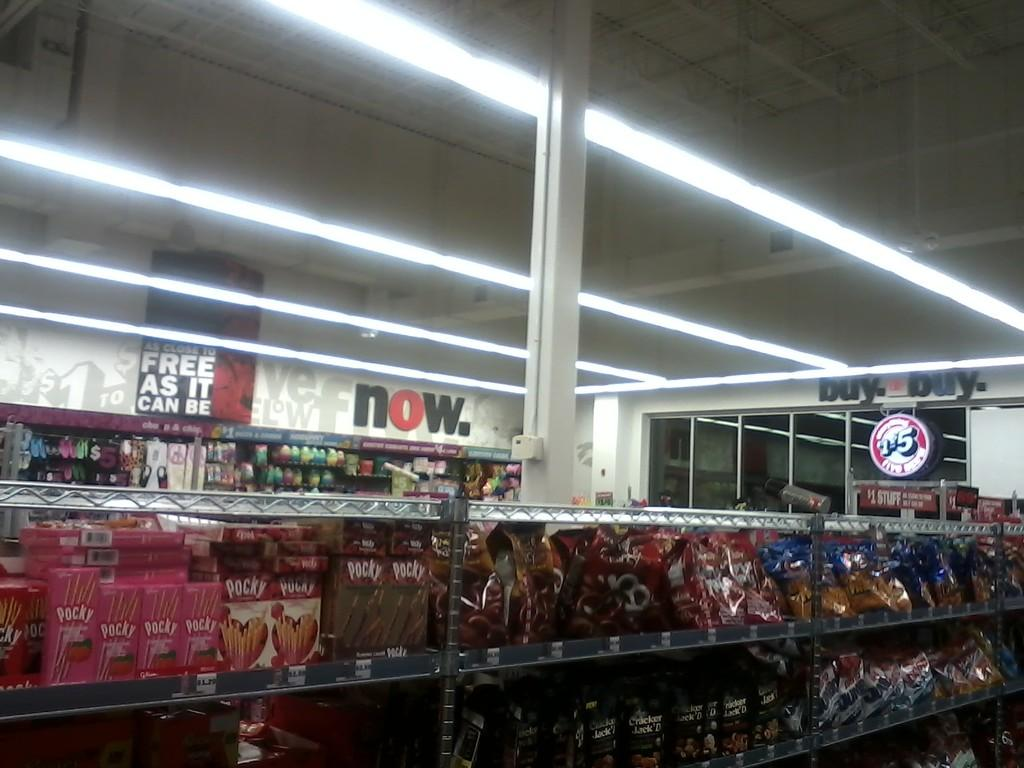<image>
Offer a succinct explanation of the picture presented. Above the grocery store aisle, there are signs about things being almost free. 